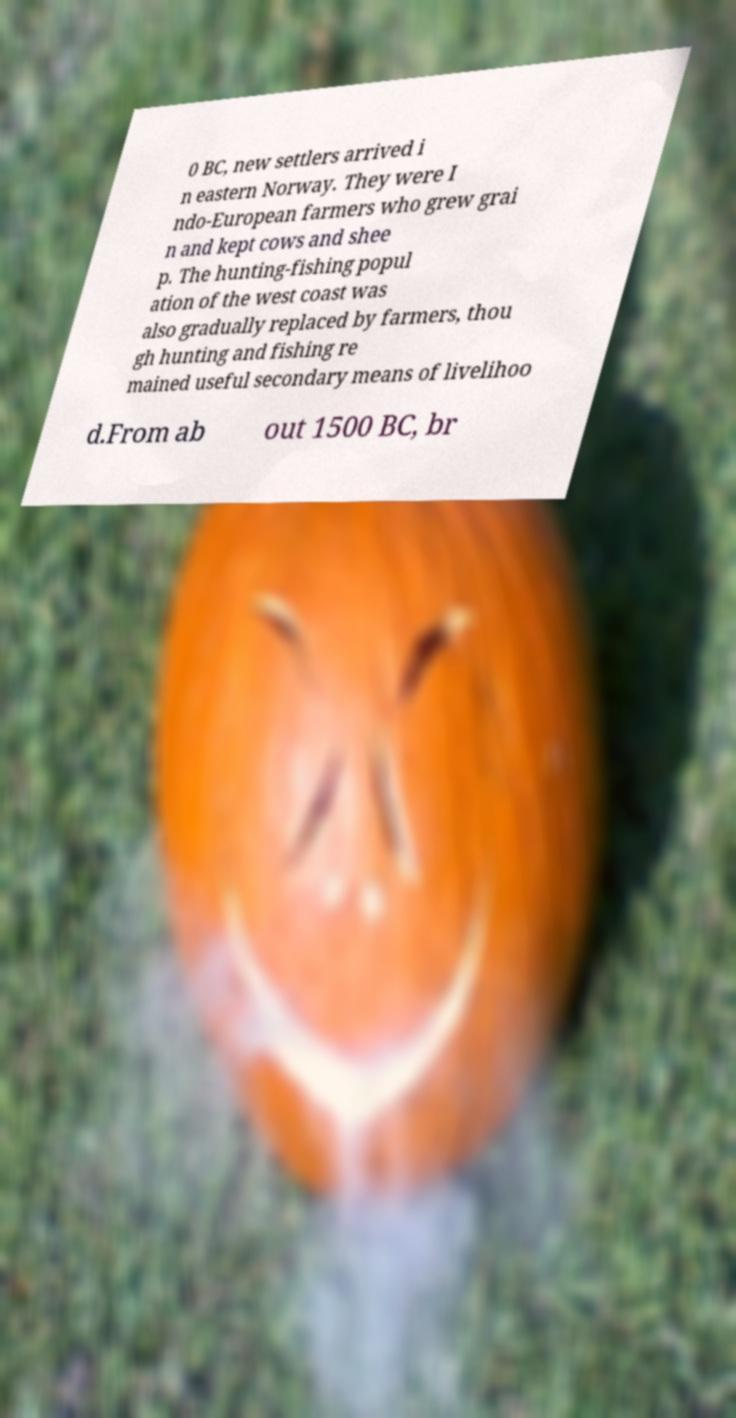Can you accurately transcribe the text from the provided image for me? 0 BC, new settlers arrived i n eastern Norway. They were I ndo-European farmers who grew grai n and kept cows and shee p. The hunting-fishing popul ation of the west coast was also gradually replaced by farmers, thou gh hunting and fishing re mained useful secondary means of livelihoo d.From ab out 1500 BC, br 